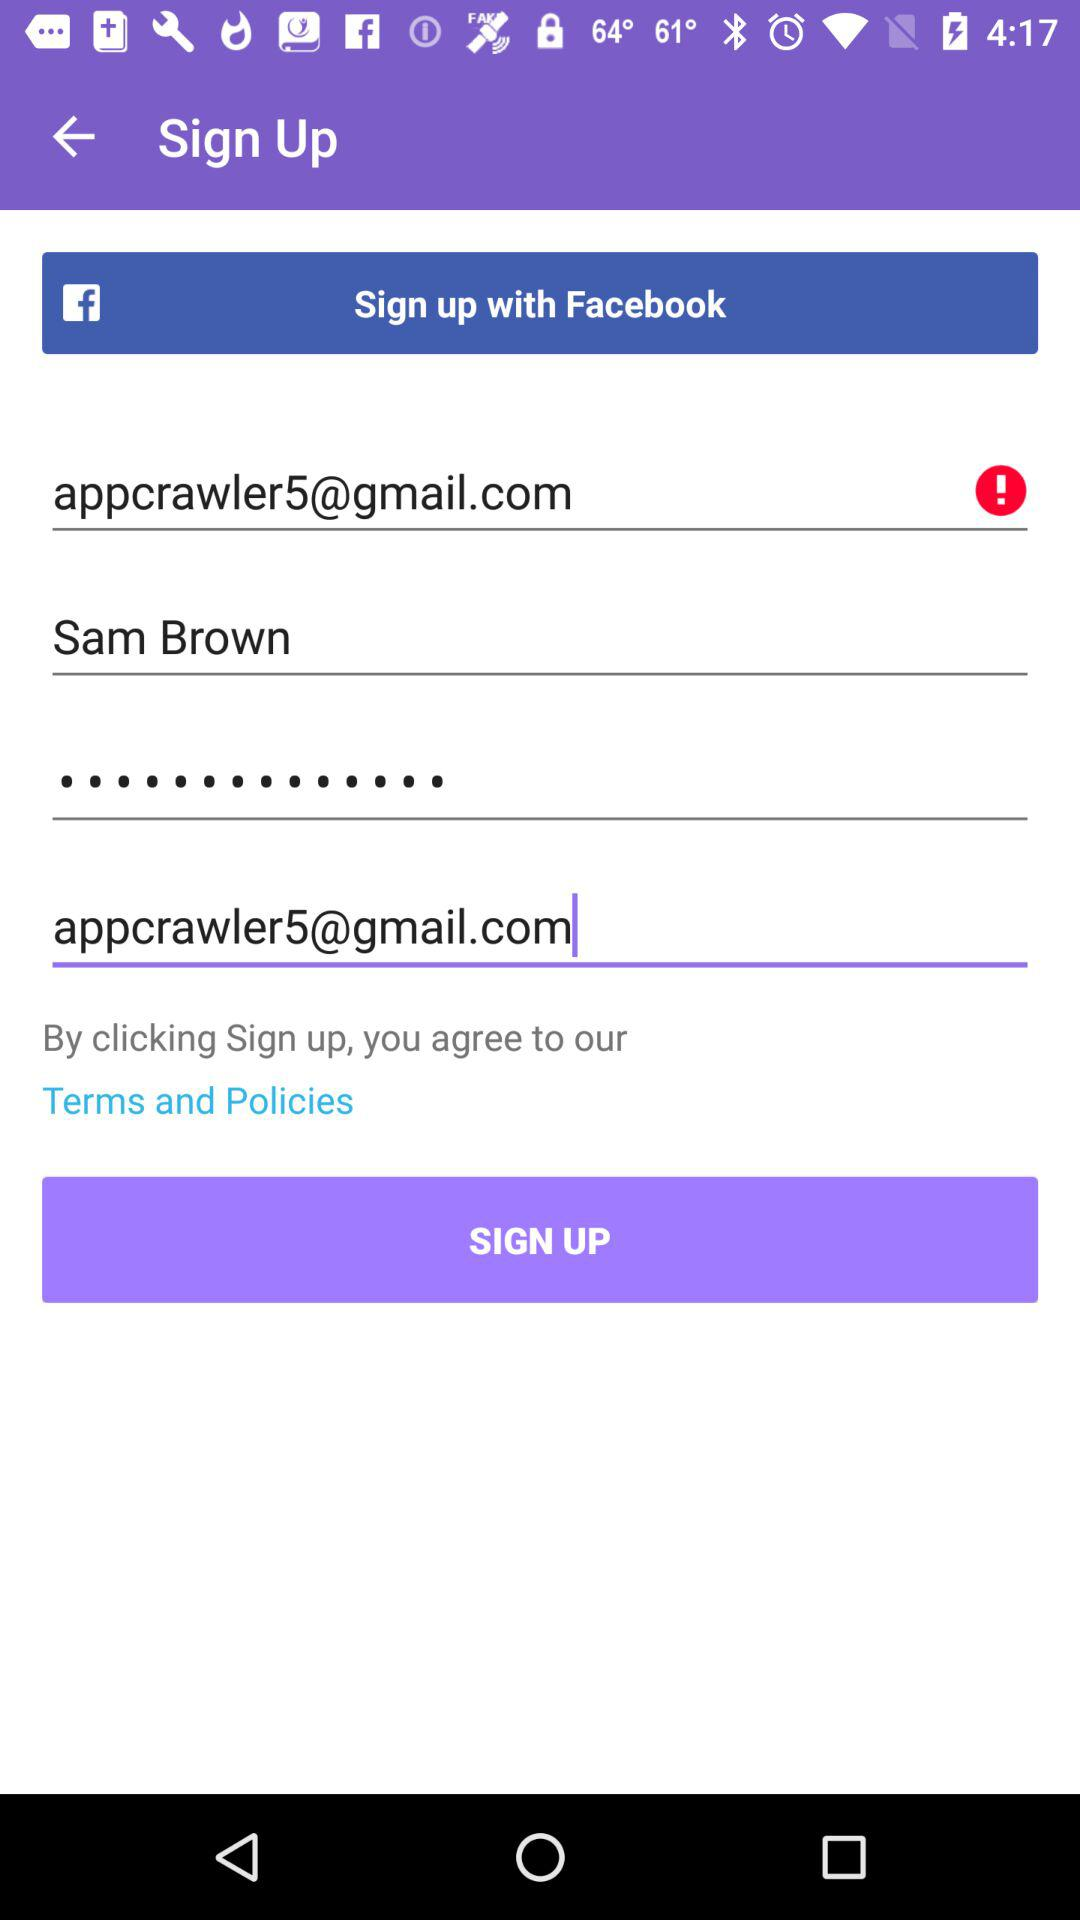Through what account can sign up be done? Sign up can be done through "Facebook" account. 